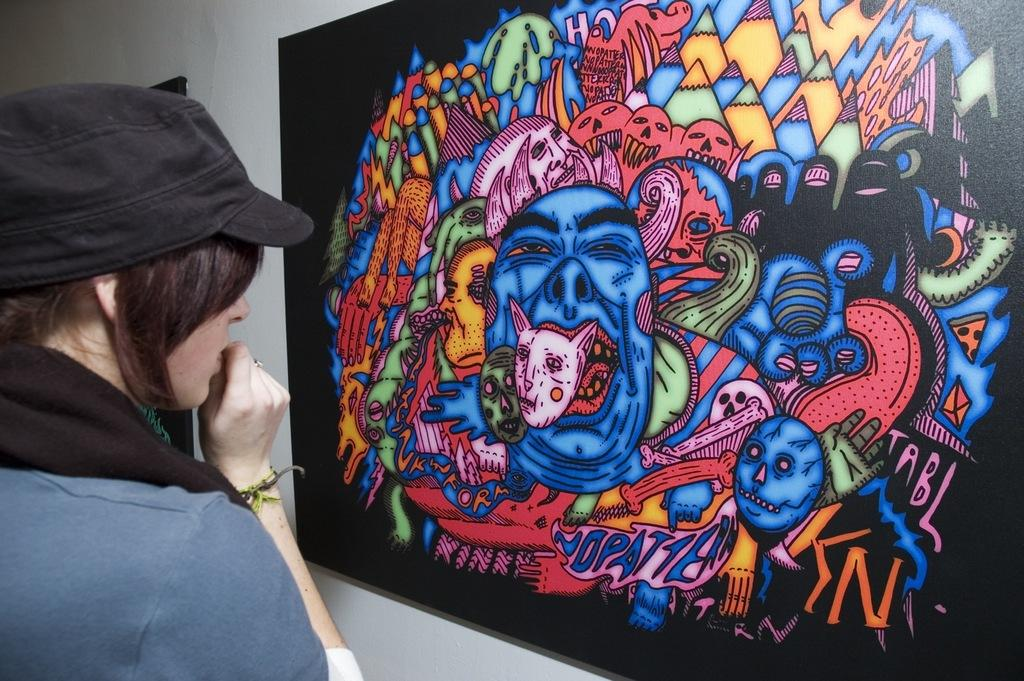Who is present in the image? There is a woman in the image. What is the woman wearing on her head? The woman is wearing a cap. What is the woman standing in front of? The woman is standing in front of a board attached to a wall. What can be seen on the board? There is a painting on the board. What channel is the woman watching on the board in the image? There is no channel or television present in the image; it features a woman standing in front of a board with a painting on it. 